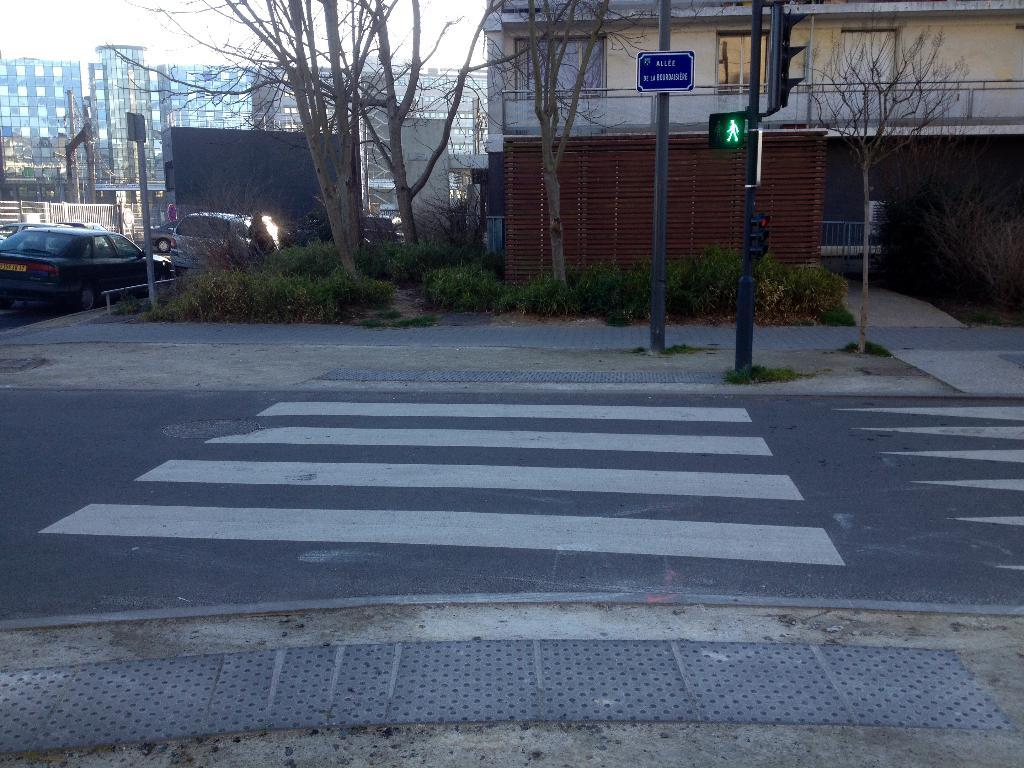What type of structures can be seen in the image? There are buildings in the image. What natural elements are present in the image? There are trees and grass on the ground in the image. What vehicles are visible in the image? Cars are parked in the image. What type of vegetation can be seen in the image? There are plants in the image. What man-made objects are present in the image? There are poles with signboards and a pole with a traffic signal light in the image. What type of event is taking place in the image? There is no indication of an event taking place in the image. --- Facts: 1. There is a person in the image. 2. The person is wearing a hat. 3. The person is holding a book. 4. The person is standing on a wooden bridge. 5. There is a river flowing under the bridge. 6. There are trees visible in the background. Absurd Topics: unicorn, spaceship, rainbow Conversation: Who or what is present in the image? There is a person in the image. What is the person wearing? The person is wearing a hat. What is the person holding? The person is holding a book. Where is the person standing? The person is standing on a wooden bridge. What is visible under the bridge? There is a river flowing under the bridge. What can be seen in the background? There are trees visible in the background. Reasoning: Let's think step by step in order to produce the conversation. We start by identifying the main subject in the image, which is the person. Then, we describe specific details about the person, such as their clothing and what they are holding. Next, we observe the person's location, noting that they are standing on a wooden bridge. We then describe the natural setting visible in the background, which includes trees. Absurd Question/Answer: Can you see a unicorn in the image? No, there is no unicorn present in the image. --- Facts: 1. There is a cat in the image. 2. The cat is sitting on a chair. 3. The chair is made of wood. 4. The cat is holding a toy mouse. 5. There is a fireplace visible in the background. 6. There is a rug on the floor in front of the chair. Absurd Topics: dragon Conversation: What type of animal can be seen in the image? There is a cat in the image. What is the cat doing? The cat is sitting on a chair. What is the chair made of? The chair is made of wood. What is the cat holding? The cat is holding a toy mouse. What can be seen in the background? There is a fireplace visible in the background 